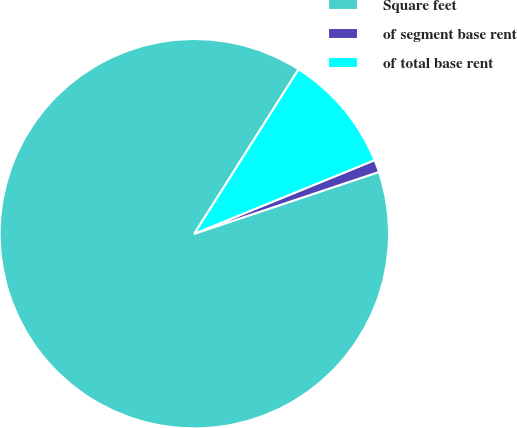<chart> <loc_0><loc_0><loc_500><loc_500><pie_chart><fcel>Square feet<fcel>of segment base rent<fcel>of total base rent<nl><fcel>89.13%<fcel>1.03%<fcel>9.84%<nl></chart> 